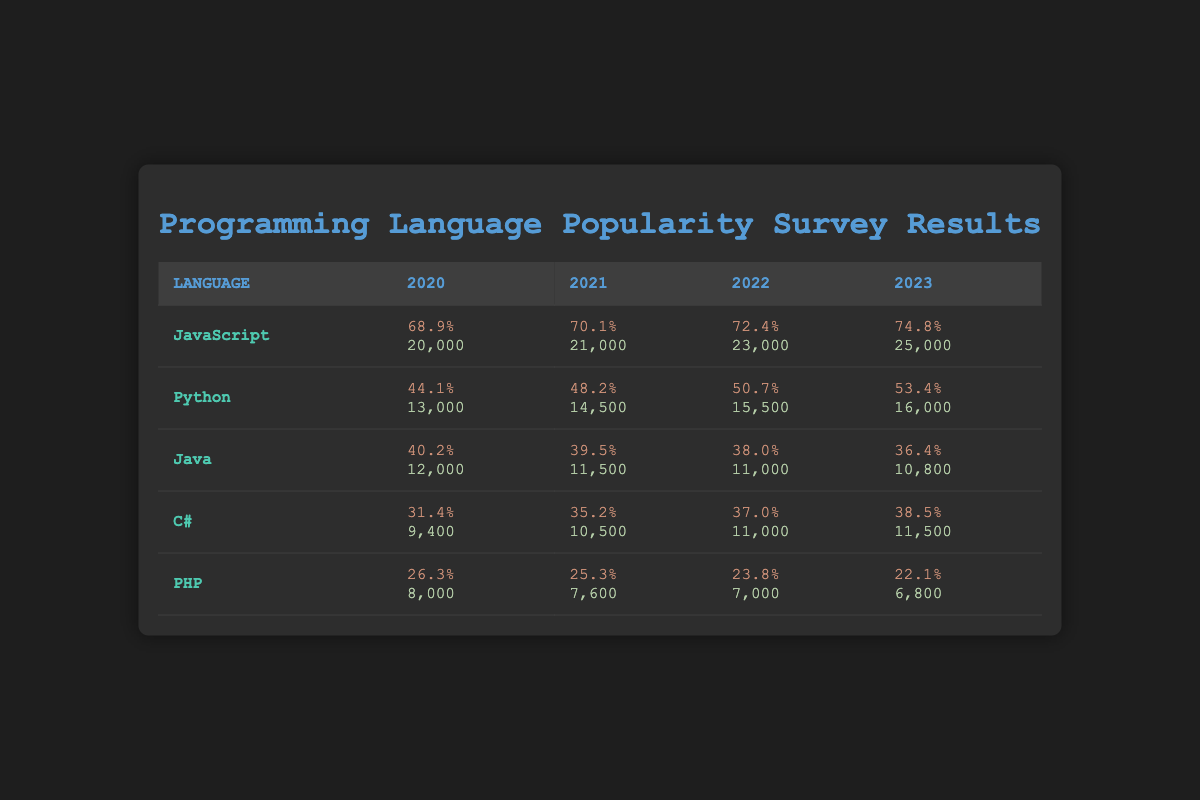What was the popularity percentage of JavaScript in 2022? According to the table, the popularity percentage of JavaScript in 2022 is indicated in the corresponding cell under the year 2022. It shows 72.4%.
Answer: 72.4% Which programming language had the highest developer count in 2021? To determine this, we compare the developer counts for each programming language in the year 2021. JavaScript has 21,000, Python has 14,500, Java has 11,500, C# has 10,500, and PHP has 7,600. JavaScript has the highest count at 21,000.
Answer: 21,000 What is the difference in popularity percentage between Python in 2023 and Java in 2023? Python's popularity percentage in 2023 is 53.4%, and Java's is 36.4%. To find the difference, we subtract Java's percentage from Python's: 53.4% - 36.4% = 17%.
Answer: 17% Is the popularity of PHP decreasing over the years from 2020 to 2023? Observing the popularity percentages for PHP over the years, we see 26.3% in 2020, 25.3% in 2021, 23.8% in 2022, and 22.1% in 2023. All these values show a decreasing trend, therefore the statement is true.
Answer: Yes What was the average developer count for C# from 2020 to 2023? First, we find the developer counts for C# each year: 9,400 in 2020, 10,500 in 2021, 11,000 in 2022, and 11,500 in 2023. We sum those values: 9,400 + 10,500 + 11,000 + 11,500 = 42,400. Dividing by the number of years (4), we get an average of 10,600.
Answer: 10,600 Which programming language saw the largest increase in popularity percentage from 2020 to 2023? We compare the popularity percentages for all languages in 2020 and 2023. JavaScript increased from 68.9% to 74.8%, a change of 5.9%. Python went from 44.1% to 53.4%, an increase of 9.3%. C# increased from 31.4% to 38.5%, an increase of 7.1%. Java decreased from 40.2% to 36.4%, and PHP decreased from 26.3% to 22.1%. From this comparison, Python had the largest increase of 9.3%.
Answer: Python What was the total developer count for Java and C# in 2022? In 2022, the developer count for Java is 11,000 and for C# is also 11,000. We add these two numbers together: 11,000 + 11,000 = 22,000.
Answer: 22,000 Was there any year where Python was more popular than Java? Looking at the popularity percentages for Python and Java from 2020 to 2023: Python had 44.1% in 2020, 48.2% in 2021, 50.7% in 2022, and 53.4% in 2023, while Java had 40.2% in 2020, 39.5% in 2021, 38.0% in 2022, and 36.4% in 2023. Python is consistently more popular than Java for all years.
Answer: Yes 